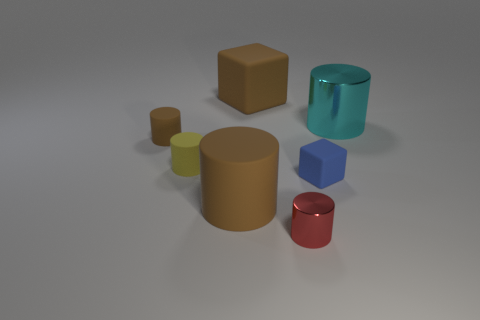Subtract all tiny brown rubber cylinders. How many cylinders are left? 4 Add 1 green blocks. How many objects exist? 8 Subtract all brown balls. How many brown cylinders are left? 2 Subtract all red cylinders. How many cylinders are left? 4 Subtract all blocks. How many objects are left? 5 Subtract 0 purple cylinders. How many objects are left? 7 Subtract all yellow cubes. Subtract all red cylinders. How many cubes are left? 2 Subtract all yellow rubber cylinders. Subtract all big gray metallic things. How many objects are left? 6 Add 6 big matte blocks. How many big matte blocks are left? 7 Add 5 big cyan shiny cylinders. How many big cyan shiny cylinders exist? 6 